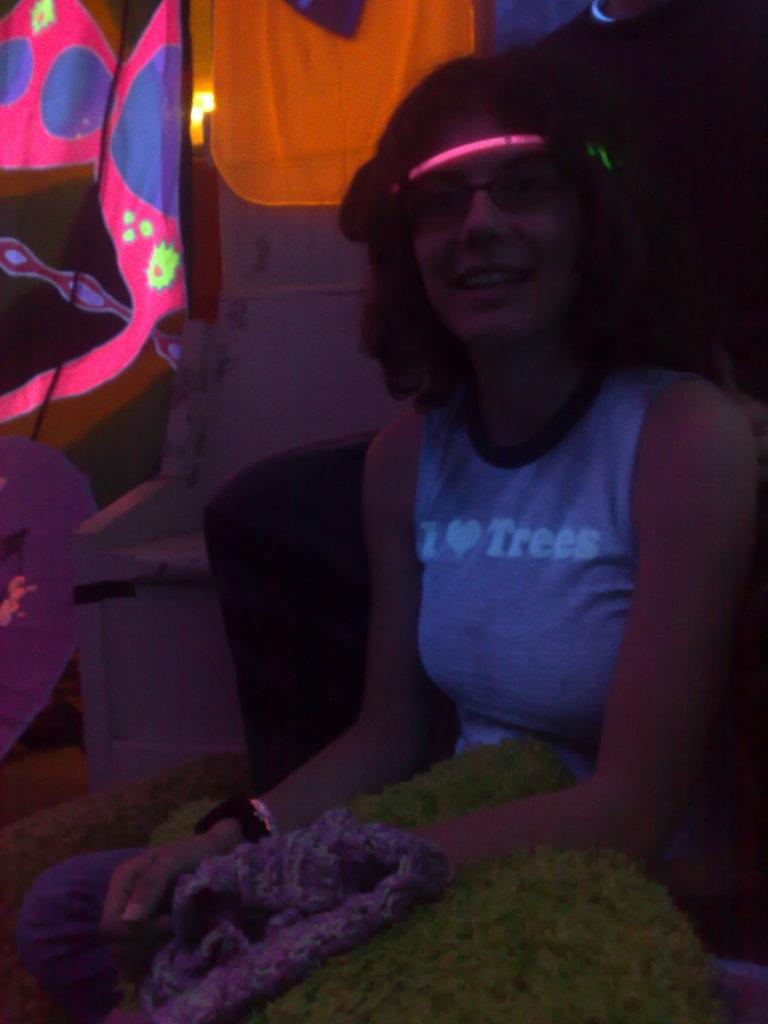What is the woman in the image doing? The woman is sitting in the image. What can be seen in the background behind the woman? There are banners behind the woman. What is the woman holding in her hand? The woman is holding a cloth. What type of vegetable is the woman holding in the image? There is no vegetable present in the image; the woman is holding a cloth. 